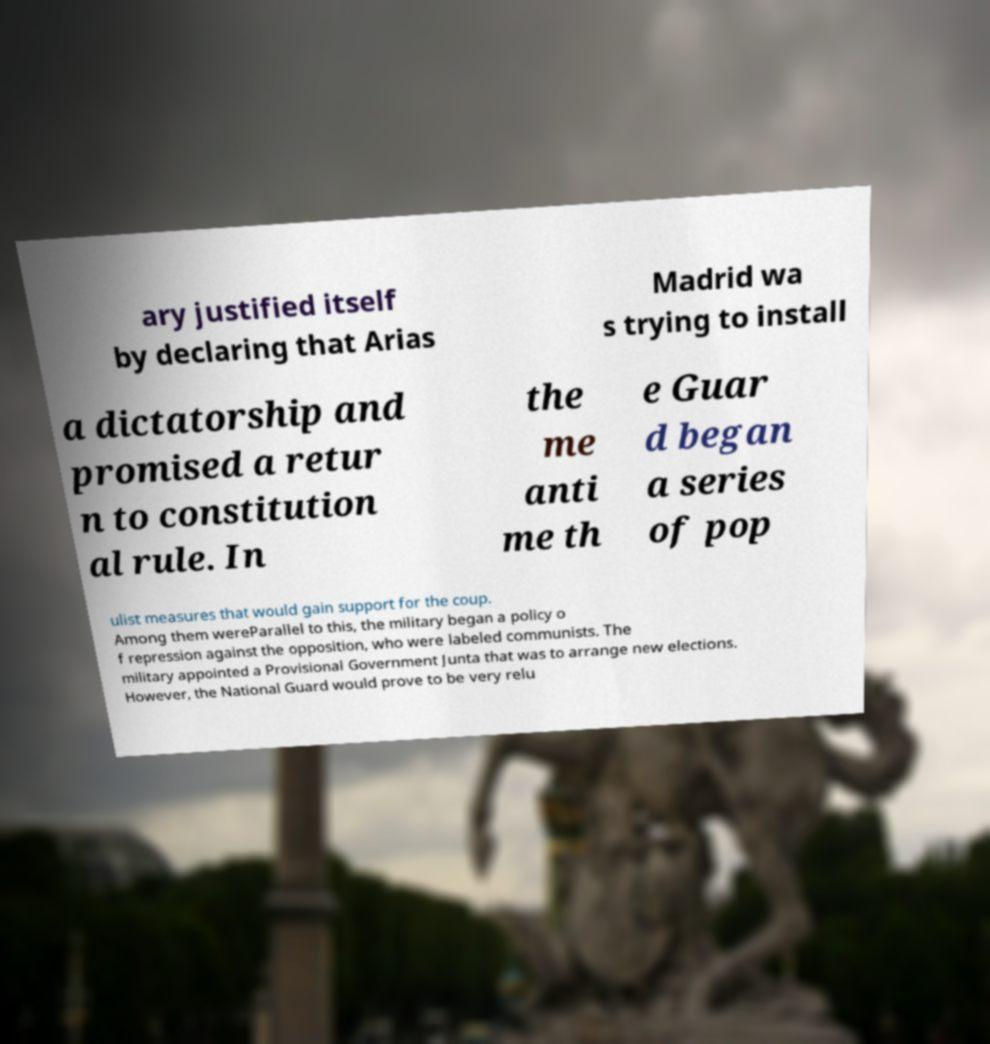Could you assist in decoding the text presented in this image and type it out clearly? ary justified itself by declaring that Arias Madrid wa s trying to install a dictatorship and promised a retur n to constitution al rule. In the me anti me th e Guar d began a series of pop ulist measures that would gain support for the coup. Among them wereParallel to this, the military began a policy o f repression against the opposition, who were labeled communists. The military appointed a Provisional Government Junta that was to arrange new elections. However, the National Guard would prove to be very relu 